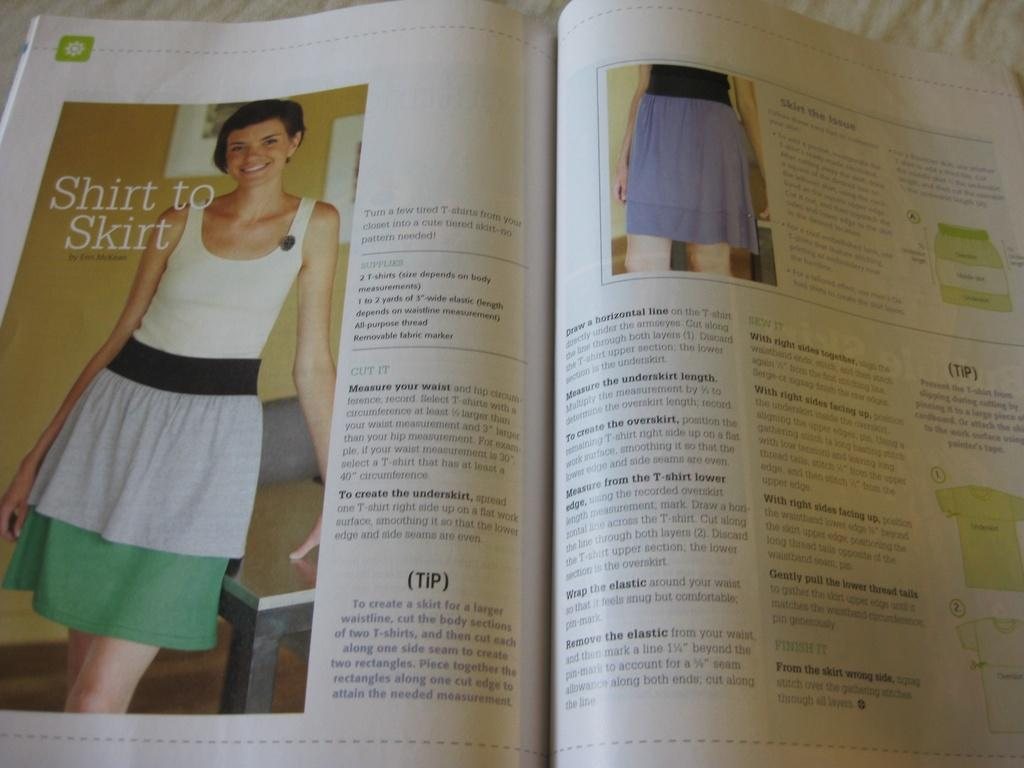<image>
Render a clear and concise summary of the photo. A magazine article entitled Shirt to Skirt shows a photo of a young woman. 